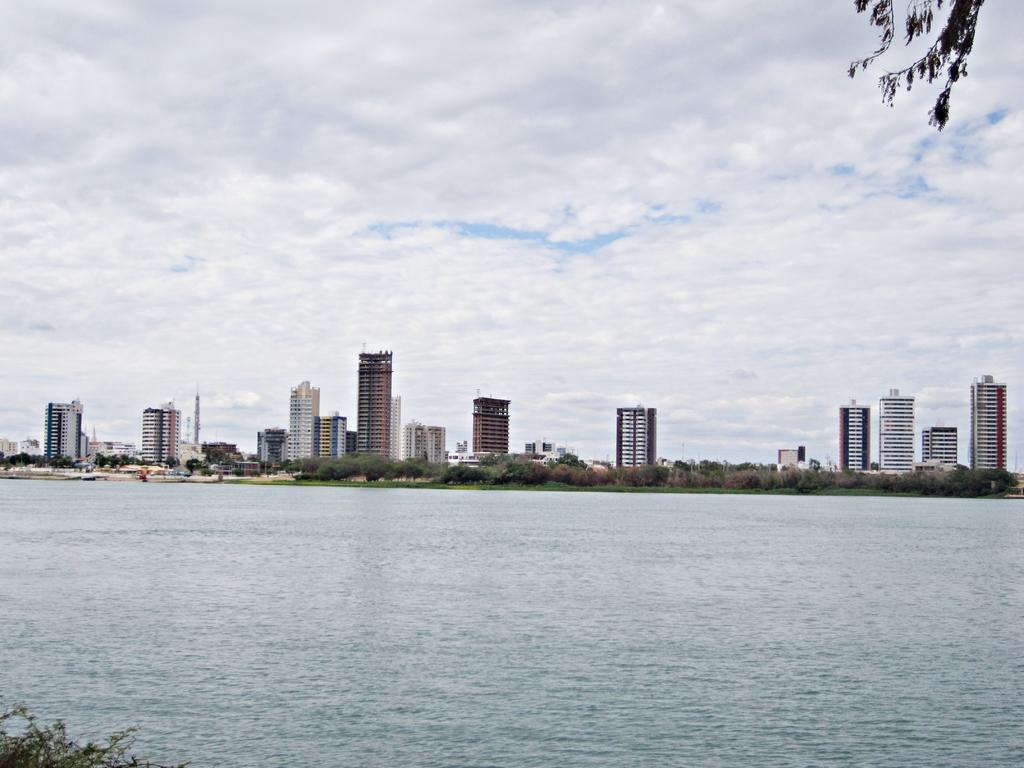What type of natural environment is depicted in the image? The image contains the sea. What type of vegetation can be seen in the image? There are trees and grass in the image. What type of man-made structures are present in the image? There are buildings in the image. What is visible in the background of the image? The sky is visible in the background of the image. What can be observed in the sky? Clouds are present in the sky. What type of tub is visible in the image? There is no tub present in the image. How does the behavior of the clouds affect the image? The image does not depict any behavior of the clouds; it only shows their presence in the sky. 